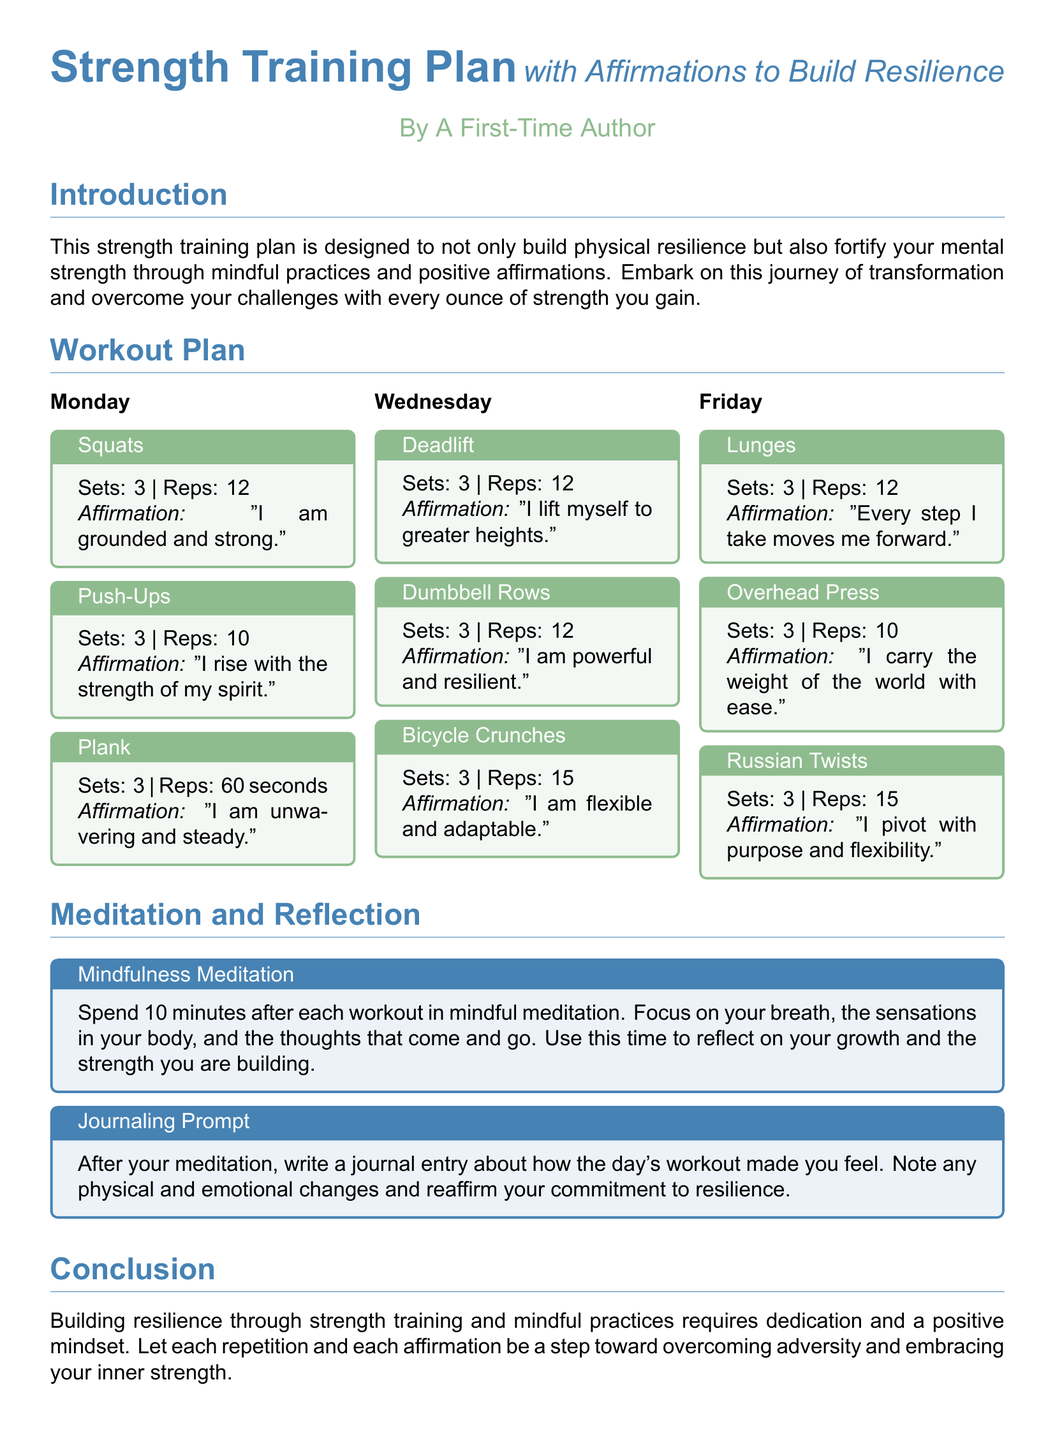What is the title of the document? The title of the document is the primary heading presented at the top, indicating the subject matter.
Answer: Strength Training Plan with Affirmations to Build Resilience How many sets are prescribed for Squats? The number of sets for Squats is listed next to the exercise within the Monday workout block.
Answer: 3 What affirmation accompanies Deadlift? The affirmation for Deadlift is specified in the associated exercise block on Wednesday.
Answer: I lift myself to greater heights How long should a Plank be held? The duration for holding a Plank is mentioned in the workout details for Monday.
Answer: 60 seconds What day of the week features Lunges? The day for the Lunges exercise is indicated in the workout schedule.
Answer: Friday How many repetitions are suggested for Bicycle Crunches? The number of repetitions for Bicycle Crunches is stated in the workout details on Wednesday.
Answer: 15 What meditation duration is recommended post-workout? The document specifies the time allocated for mindful meditation after workouts.
Answer: 10 minutes Which exercise requires the use of Dumbbell Rows? The particular exercise that includes Dumbbell Rows is highlighted in the workout section for Wednesday.
Answer: Dumbbell Rows What color is used for the affirmation boxes? The color used for the affirmation boxes is described in terms of its hue in the layout.
Answer: Calm green 